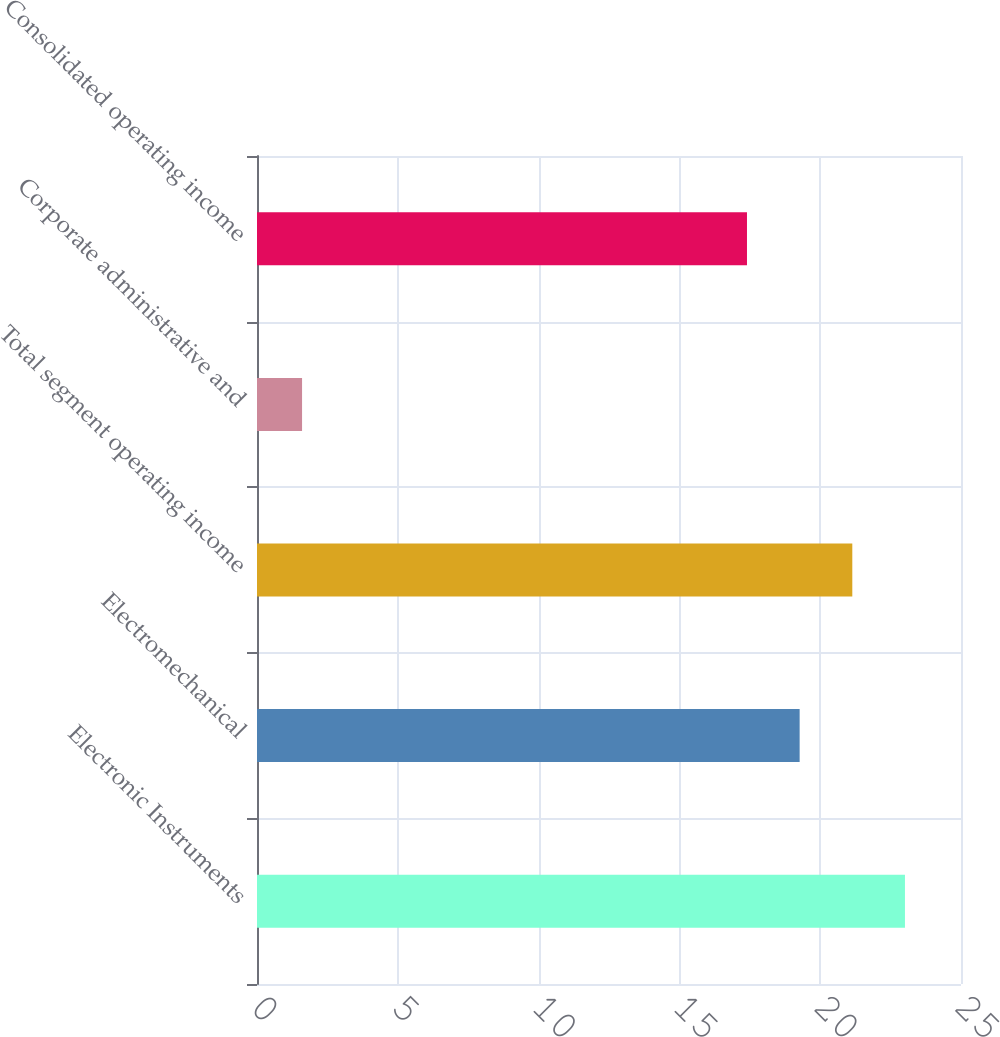Convert chart. <chart><loc_0><loc_0><loc_500><loc_500><bar_chart><fcel>Electronic Instruments<fcel>Electromechanical<fcel>Total segment operating income<fcel>Corporate administrative and<fcel>Consolidated operating income<nl><fcel>23.01<fcel>19.27<fcel>21.14<fcel>1.6<fcel>17.4<nl></chart> 